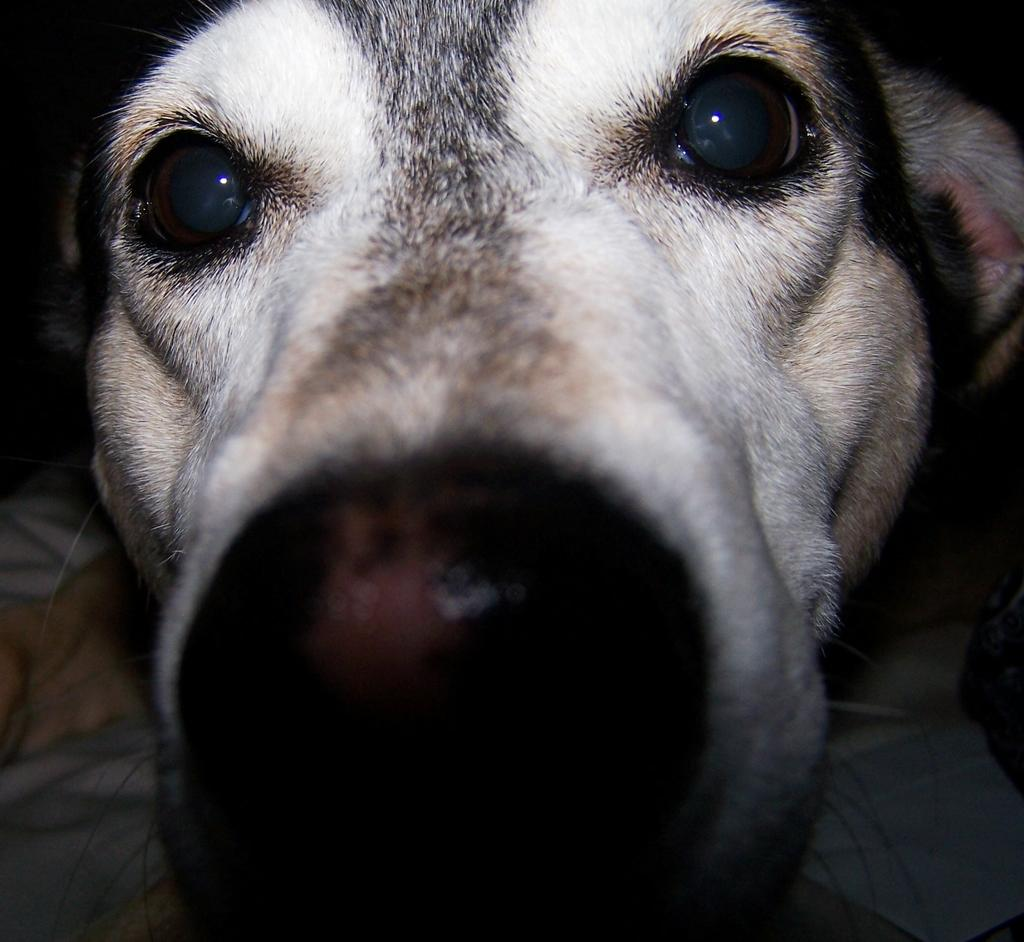What animal is present in the image? There is a dog in the image. What is the dog positioned on? The dog is on a cloth. Can you see any ghosts interacting with the dog in the image? There are no ghosts present in the image. 